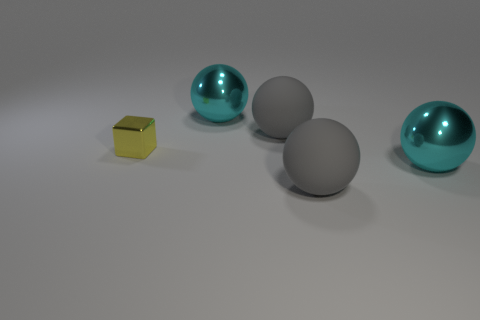Is there any other thing that has the same size as the yellow metallic cube?
Make the answer very short. No. The shiny thing behind the small thing has what shape?
Provide a succinct answer. Sphere. Is the material of the gray thing that is behind the yellow metallic thing the same as the gray ball that is in front of the small shiny object?
Offer a very short reply. Yes. How many objects are big gray rubber balls in front of the shiny cube or big yellow spheres?
Offer a terse response. 1. What number of shiny things are cyan spheres or yellow objects?
Keep it short and to the point. 3. How many objects are either purple rubber blocks or shiny objects behind the small metallic block?
Offer a very short reply. 1. What number of other objects are there of the same material as the yellow thing?
Offer a terse response. 2. The small shiny thing is what color?
Your answer should be very brief. Yellow. What is the shape of the large matte object that is in front of the small cube to the left of the big cyan shiny ball that is in front of the tiny metal block?
Give a very brief answer. Sphere. What material is the gray object that is to the right of the gray thing that is behind the yellow thing?
Your answer should be very brief. Rubber. 